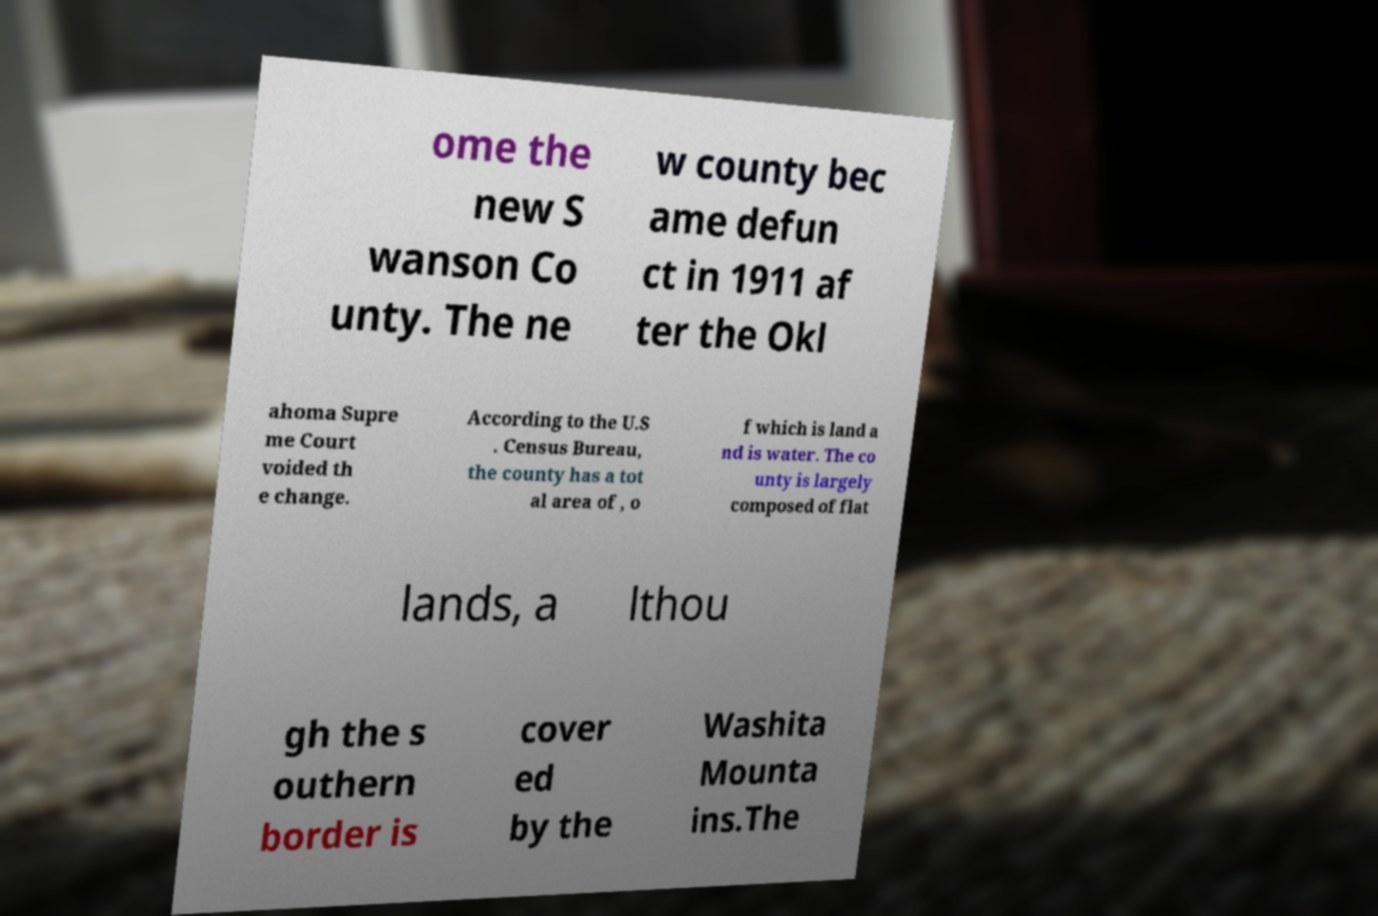Could you assist in decoding the text presented in this image and type it out clearly? ome the new S wanson Co unty. The ne w county bec ame defun ct in 1911 af ter the Okl ahoma Supre me Court voided th e change. According to the U.S . Census Bureau, the county has a tot al area of , o f which is land a nd is water. The co unty is largely composed of flat lands, a lthou gh the s outhern border is cover ed by the Washita Mounta ins.The 